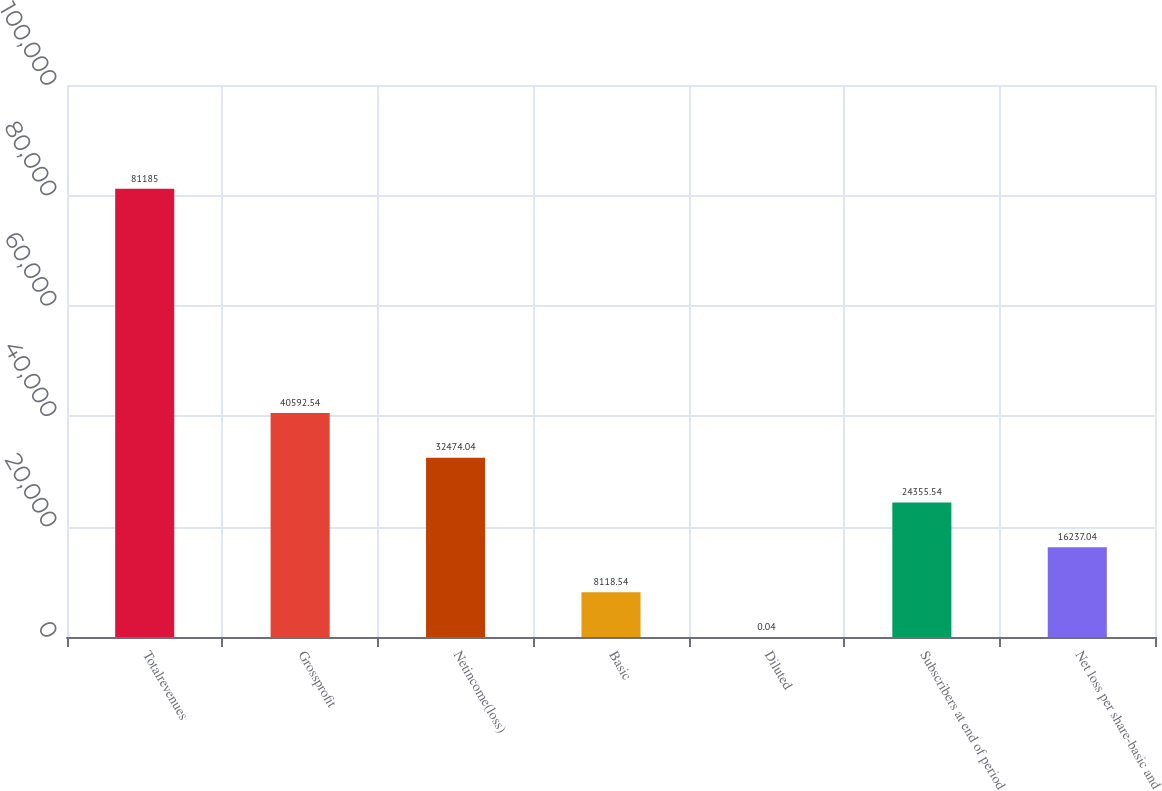Convert chart. <chart><loc_0><loc_0><loc_500><loc_500><bar_chart><fcel>Totalrevenues<fcel>Grossprofit<fcel>Netincome(loss)<fcel>Basic<fcel>Diluted<fcel>Subscribers at end of period<fcel>Net loss per share-basic and<nl><fcel>81185<fcel>40592.5<fcel>32474<fcel>8118.54<fcel>0.04<fcel>24355.5<fcel>16237<nl></chart> 